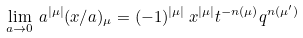Convert formula to latex. <formula><loc_0><loc_0><loc_500><loc_500>\lim _ { a \rightarrow 0 } \, a ^ { | \mu | } ( x / a ) _ { \mu } = ( - 1 ) ^ { | \mu | } \, x ^ { | \mu | } t ^ { - n ( \mu ) } q ^ { n ( \mu ^ { \prime } ) }</formula> 